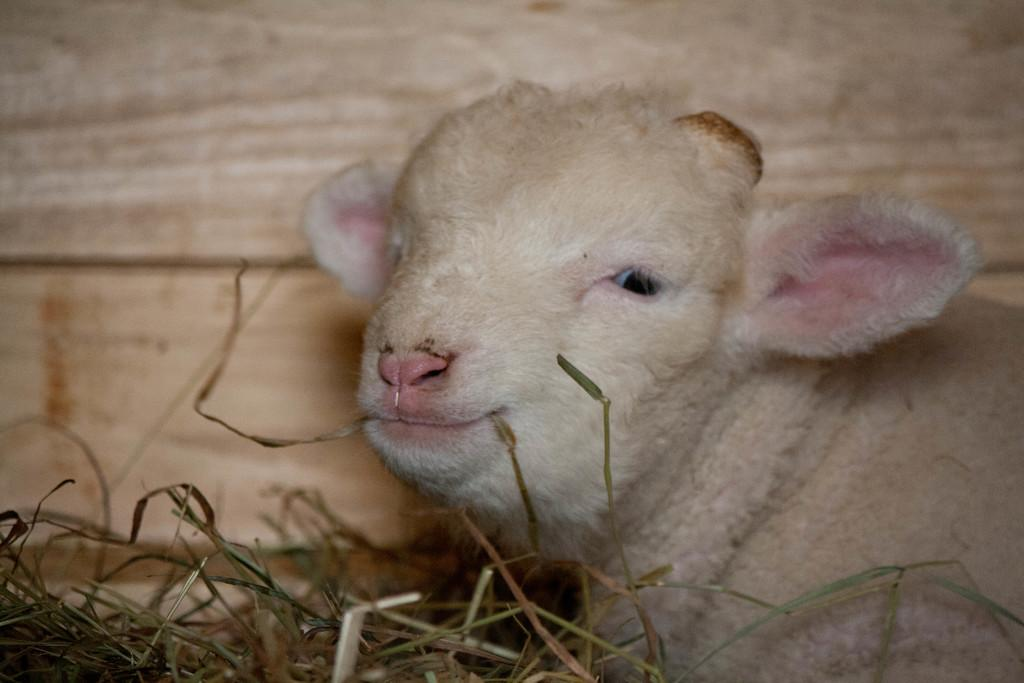What type of animal is in the image? There is a baby goat in the image. What is the baby goat doing in the image? The baby goat is sitting on the ground. What type of vegetation is on the ground in the image? There are dry grass on the ground in the image. What channel is the baby goat watching in the image? There is no television or channel present in the image, as it features a baby goat sitting on the ground with dry grass. 